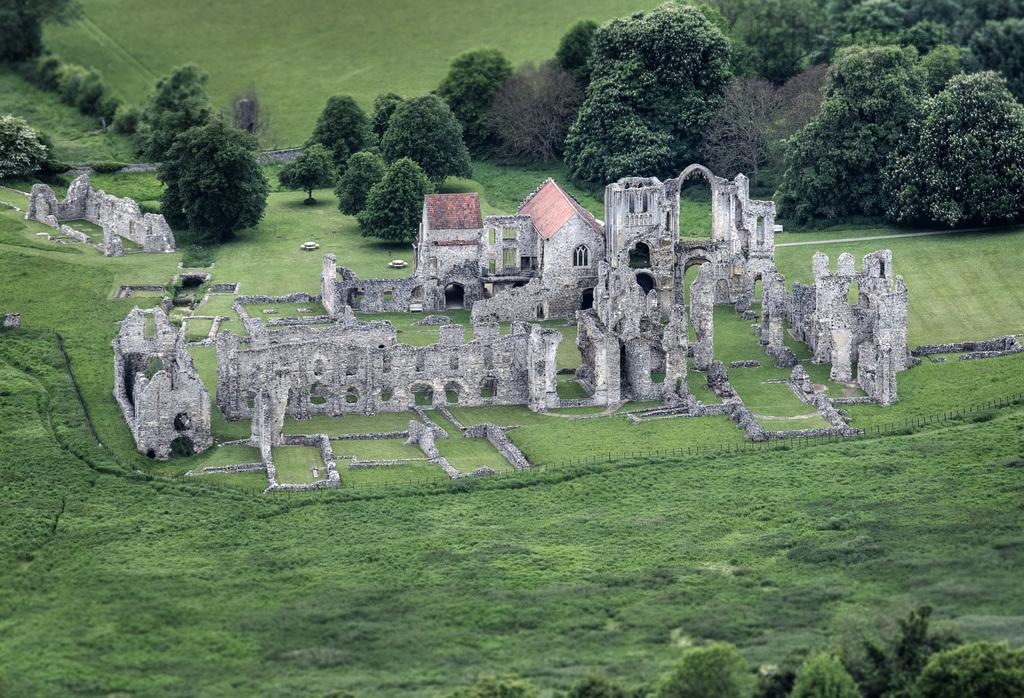What type of structures can be seen in the image? There are houses in the image. What is the wall in the image like? The wall in the image has windows. What is the landscape around the houses like? The area around the houses is full of grass. What type of vegetation is present in the image? There are trees in the image. How many balls are being played with by the boys sitting on the chair in the image? There are no balls, boys, or chairs present in the image. 